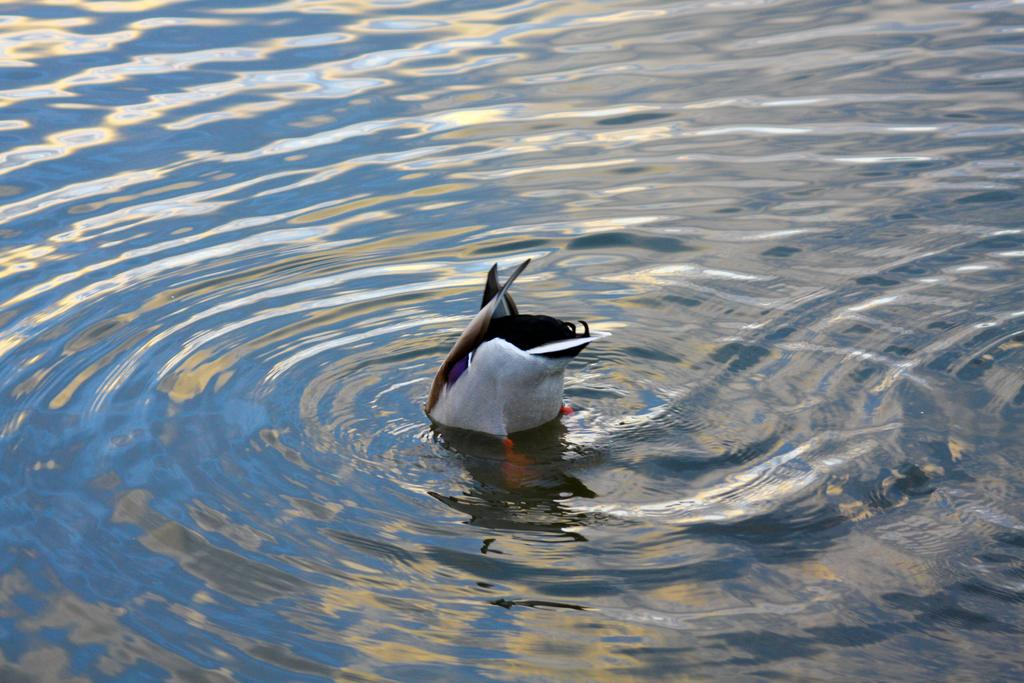What type of animal can be seen in the water in the image? There is a bird in the water in the image. Can you describe the bird's location in the image? The bird is in the water in the image. What type of can is visible in the image? There is no can present in the image; it features a bird in the water. What type of agreement is being made between the bird and the plate in the image? There is no plate present in the image, and the bird is not making any agreements. 